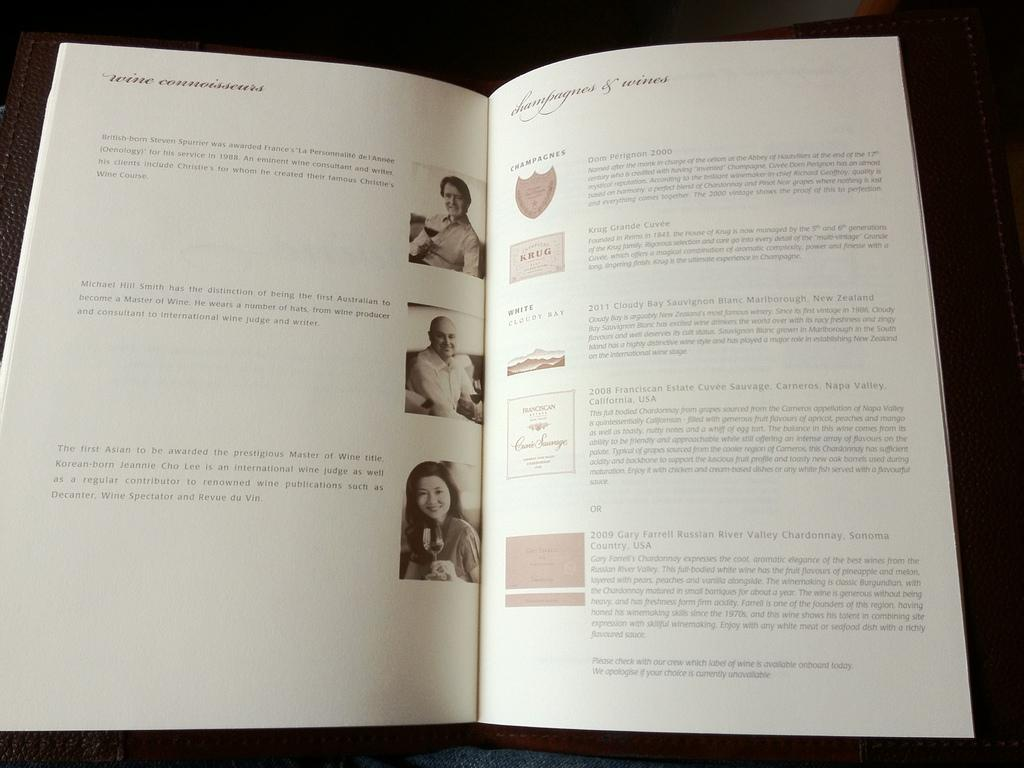<image>
Write a terse but informative summary of the picture. the word wine that is on a page of a book 